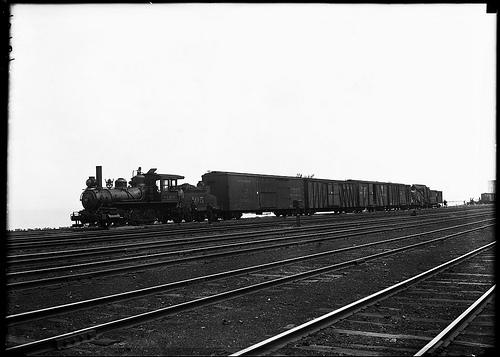Is this an old picture?
Answer briefly. Yes. What color train is on the track?
Quick response, please. Black. Are there clouds in the sky?
Keep it brief. No. Are the trains two toned?
Concise answer only. No. Where was the picture taken of the tracks?
Give a very brief answer. Yes. Is this a passenger train?
Write a very short answer. No. What season does it appear to be?
Short answer required. Winter. 